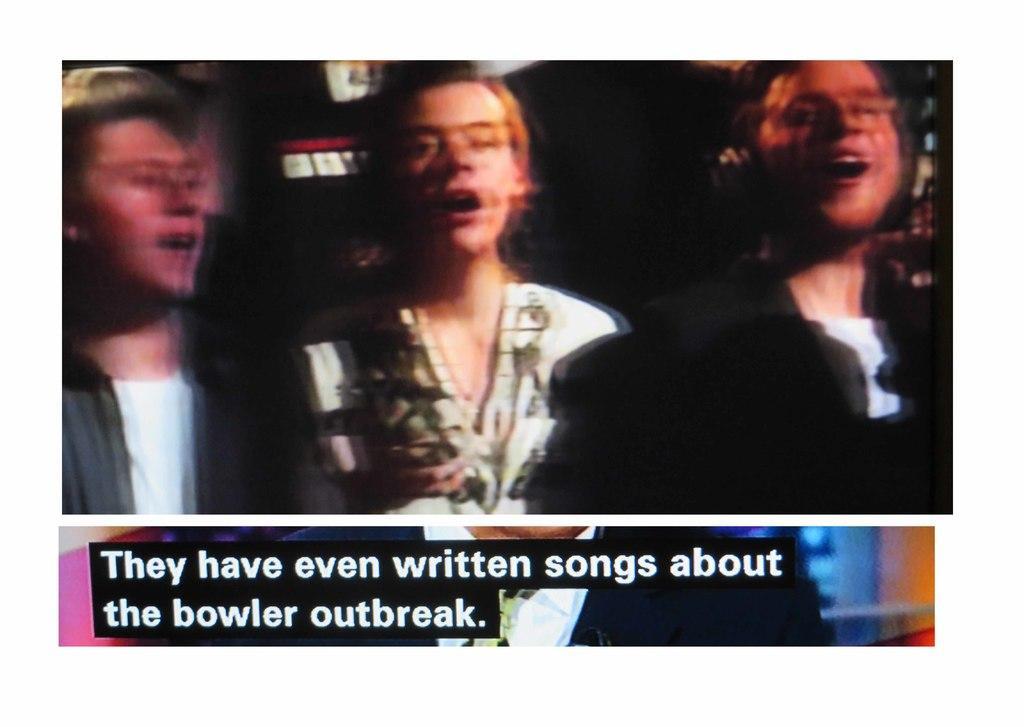Can you describe this image briefly? It is a blur image, it looks like there are three people and below the picture there is some statement mentioned down the picture. 